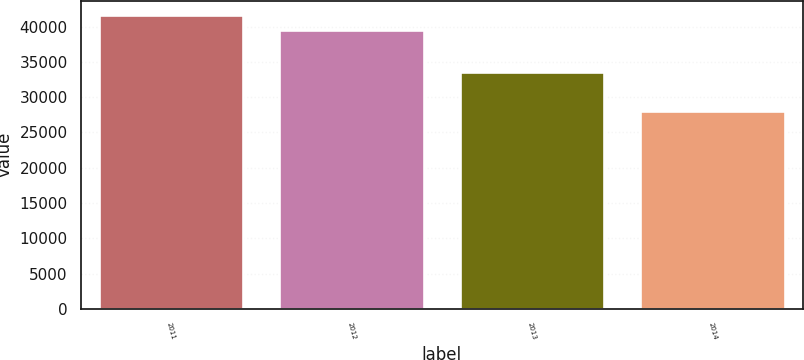Convert chart to OTSL. <chart><loc_0><loc_0><loc_500><loc_500><bar_chart><fcel>2011<fcel>2012<fcel>2013<fcel>2014<nl><fcel>41597<fcel>39565<fcel>33505<fcel>28021<nl></chart> 